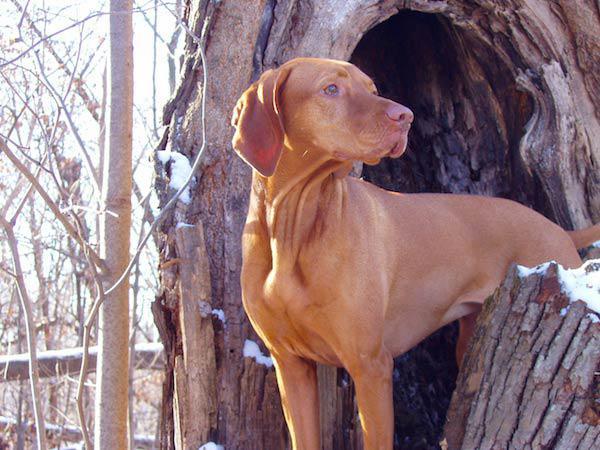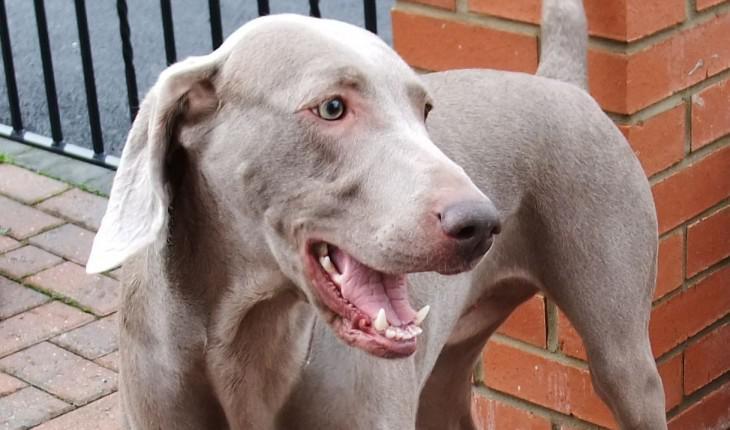The first image is the image on the left, the second image is the image on the right. Evaluate the accuracy of this statement regarding the images: "There are 3 dogs in one of the images and only 1 dog in the other image.". Is it true? Answer yes or no. No. The first image is the image on the left, the second image is the image on the right. Considering the images on both sides, is "The combined images include three dogs posed in a row with their heads close together and at least two the same color, and a metal fence by a red-orange dog." valid? Answer yes or no. No. 